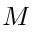Convert formula to latex. <formula><loc_0><loc_0><loc_500><loc_500>M</formula> 